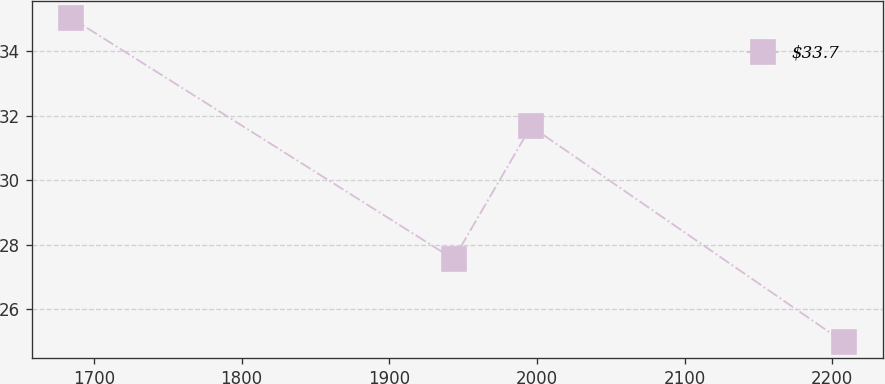Convert chart to OTSL. <chart><loc_0><loc_0><loc_500><loc_500><line_chart><ecel><fcel>$33.7<nl><fcel>1684.08<fcel>35.05<nl><fcel>1943.56<fcel>27.55<nl><fcel>1995.95<fcel>31.67<nl><fcel>2207.95<fcel>24.97<nl></chart> 